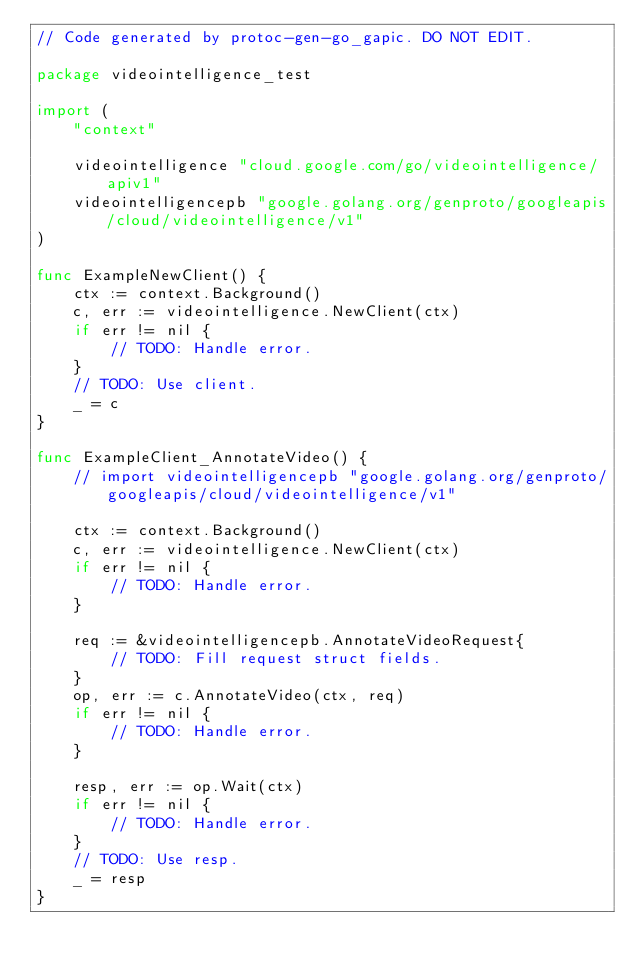Convert code to text. <code><loc_0><loc_0><loc_500><loc_500><_Go_>// Code generated by protoc-gen-go_gapic. DO NOT EDIT.

package videointelligence_test

import (
	"context"

	videointelligence "cloud.google.com/go/videointelligence/apiv1"
	videointelligencepb "google.golang.org/genproto/googleapis/cloud/videointelligence/v1"
)

func ExampleNewClient() {
	ctx := context.Background()
	c, err := videointelligence.NewClient(ctx)
	if err != nil {
		// TODO: Handle error.
	}
	// TODO: Use client.
	_ = c
}

func ExampleClient_AnnotateVideo() {
	// import videointelligencepb "google.golang.org/genproto/googleapis/cloud/videointelligence/v1"

	ctx := context.Background()
	c, err := videointelligence.NewClient(ctx)
	if err != nil {
		// TODO: Handle error.
	}

	req := &videointelligencepb.AnnotateVideoRequest{
		// TODO: Fill request struct fields.
	}
	op, err := c.AnnotateVideo(ctx, req)
	if err != nil {
		// TODO: Handle error.
	}

	resp, err := op.Wait(ctx)
	if err != nil {
		// TODO: Handle error.
	}
	// TODO: Use resp.
	_ = resp
}
</code> 